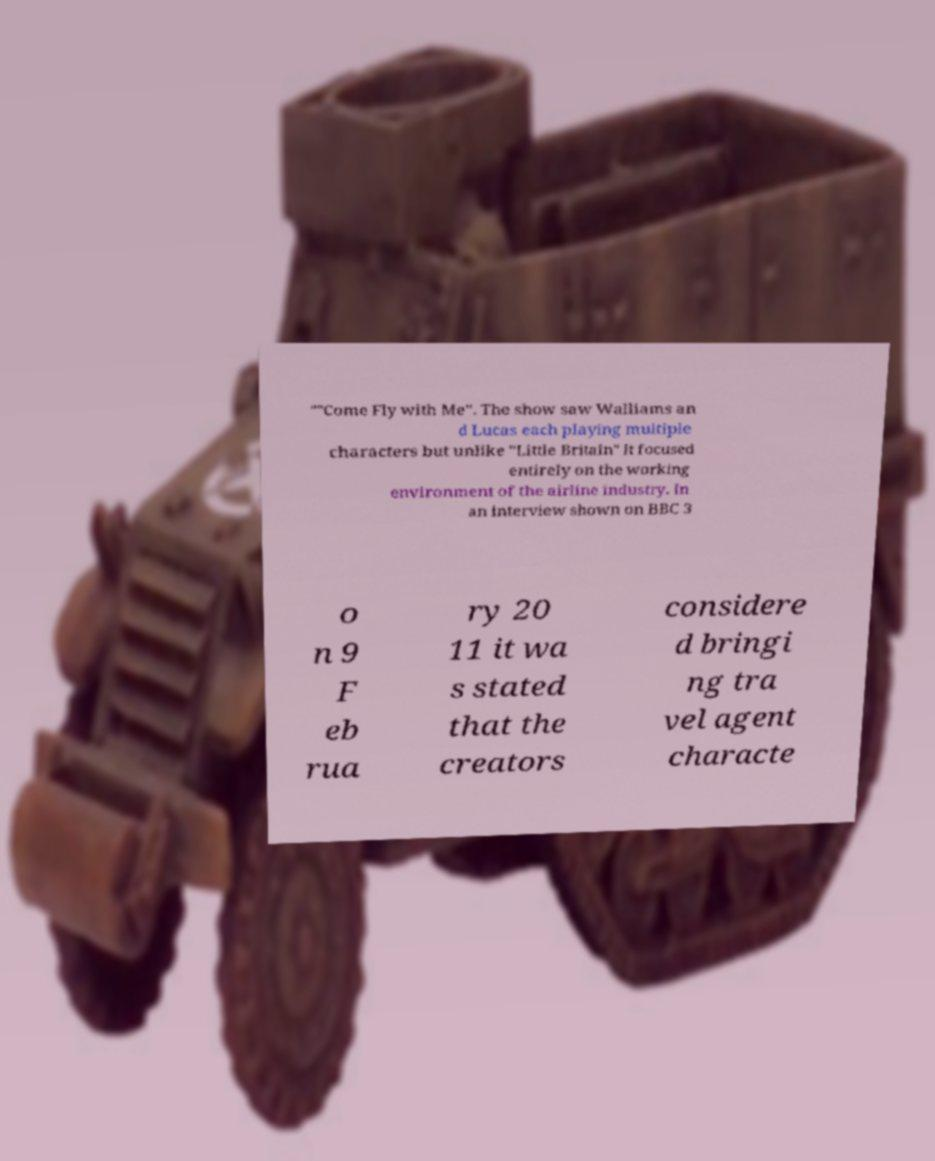Can you read and provide the text displayed in the image?This photo seems to have some interesting text. Can you extract and type it out for me? ""Come Fly with Me". The show saw Walliams an d Lucas each playing multiple characters but unlike "Little Britain" it focused entirely on the working environment of the airline industry. In an interview shown on BBC 3 o n 9 F eb rua ry 20 11 it wa s stated that the creators considere d bringi ng tra vel agent characte 